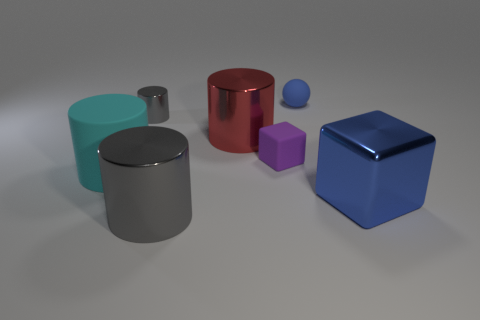Add 1 small red rubber cylinders. How many objects exist? 8 Subtract all spheres. How many objects are left? 6 Add 2 tiny blue things. How many tiny blue things are left? 3 Add 5 blue metallic objects. How many blue metallic objects exist? 6 Subtract 0 green blocks. How many objects are left? 7 Subtract all large cyan matte cylinders. Subtract all cylinders. How many objects are left? 2 